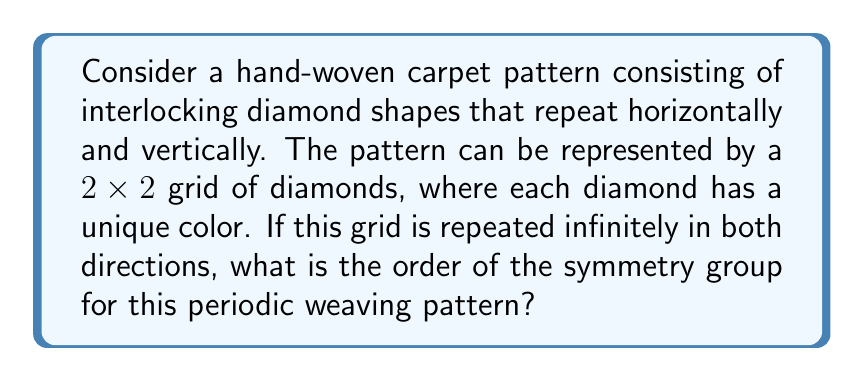Show me your answer to this math problem. Let's approach this step-by-step:

1) First, we need to identify the symmetries of the pattern:

   a) Translations: The pattern repeats horizontally and vertically, so we have two translation symmetries.
   b) Rotations: The pattern has 180° rotational symmetry around the center of each diamond and at the corners where four diamonds meet.
   c) Reflections: There are horizontal and vertical reflection lines through the centers of the diamonds and between them.

2) Now, let's count these symmetries:

   a) Translations: There are infinite translations, but in the symmetry group, we only consider the smallest non-trivial translation in each direction. So we have 2 translation symmetries.
   b) Rotations: There is a 180° rotation, which we count as 1.
   c) Reflections: There are 2 reflections (horizontal and vertical).

3) The total number of symmetries is the product of these:
   $2 \times 1 \times 2 = 4$

4) This symmetry group is isomorphic to the Klein four-group, also known as $V_4$ or $C_2 \times C_2$.

5) The order of a group is the number of elements in the group, which in this case is 4.

Therefore, the order of the symmetry group for this periodic weaving pattern is 4.
Answer: 4 